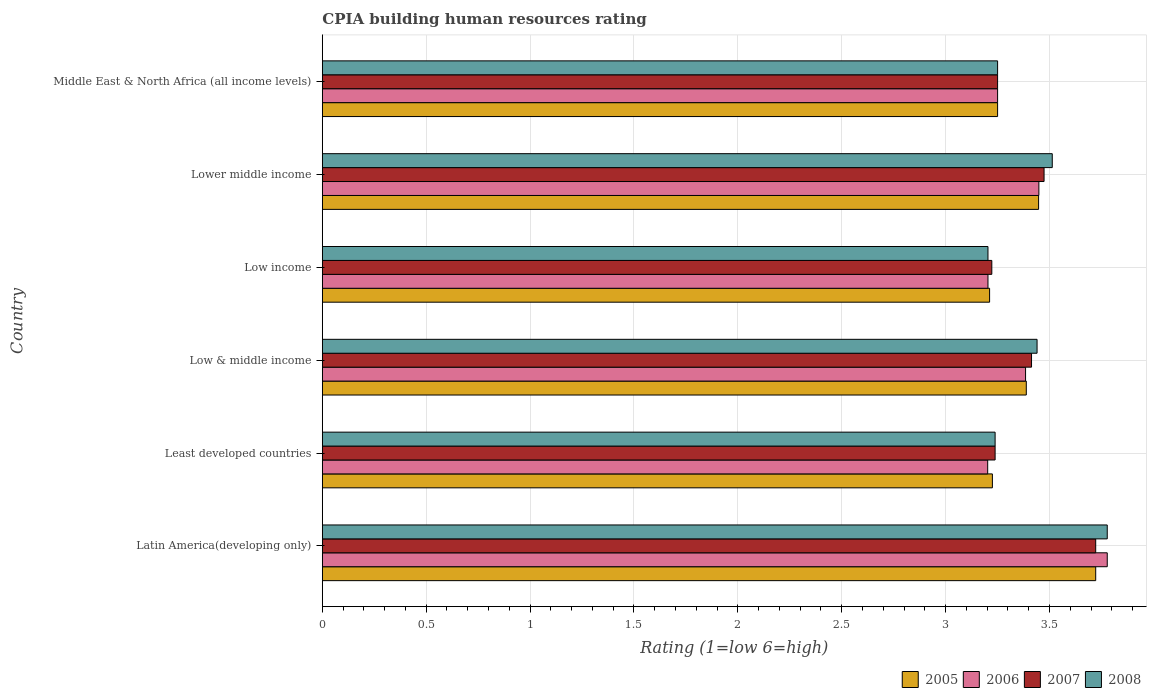How many groups of bars are there?
Keep it short and to the point. 6. Are the number of bars per tick equal to the number of legend labels?
Your answer should be very brief. Yes. How many bars are there on the 3rd tick from the top?
Give a very brief answer. 4. What is the label of the 1st group of bars from the top?
Keep it short and to the point. Middle East & North Africa (all income levels). Across all countries, what is the maximum CPIA rating in 2006?
Provide a succinct answer. 3.78. Across all countries, what is the minimum CPIA rating in 2006?
Offer a very short reply. 3.2. In which country was the CPIA rating in 2005 maximum?
Your answer should be compact. Latin America(developing only). What is the total CPIA rating in 2005 in the graph?
Offer a terse response. 20.24. What is the difference between the CPIA rating in 2006 in Latin America(developing only) and that in Low income?
Offer a very short reply. 0.57. What is the difference between the CPIA rating in 2008 in Lower middle income and the CPIA rating in 2005 in Least developed countries?
Provide a short and direct response. 0.29. What is the average CPIA rating in 2008 per country?
Offer a very short reply. 3.4. What is the difference between the CPIA rating in 2005 and CPIA rating in 2006 in Low income?
Offer a very short reply. 0.01. In how many countries, is the CPIA rating in 2008 greater than 0.1 ?
Offer a terse response. 6. What is the ratio of the CPIA rating in 2008 in Low & middle income to that in Middle East & North Africa (all income levels)?
Your answer should be compact. 1.06. What is the difference between the highest and the second highest CPIA rating in 2007?
Offer a very short reply. 0.25. What is the difference between the highest and the lowest CPIA rating in 2006?
Make the answer very short. 0.58. Is it the case that in every country, the sum of the CPIA rating in 2008 and CPIA rating in 2006 is greater than the sum of CPIA rating in 2005 and CPIA rating in 2007?
Provide a short and direct response. No. What does the 1st bar from the bottom in Lower middle income represents?
Offer a very short reply. 2005. How many bars are there?
Make the answer very short. 24. How many countries are there in the graph?
Your answer should be very brief. 6. What is the difference between two consecutive major ticks on the X-axis?
Ensure brevity in your answer.  0.5. Does the graph contain any zero values?
Offer a terse response. No. Where does the legend appear in the graph?
Make the answer very short. Bottom right. How are the legend labels stacked?
Your answer should be compact. Horizontal. What is the title of the graph?
Make the answer very short. CPIA building human resources rating. What is the Rating (1=low 6=high) of 2005 in Latin America(developing only)?
Keep it short and to the point. 3.72. What is the Rating (1=low 6=high) in 2006 in Latin America(developing only)?
Provide a succinct answer. 3.78. What is the Rating (1=low 6=high) of 2007 in Latin America(developing only)?
Give a very brief answer. 3.72. What is the Rating (1=low 6=high) of 2008 in Latin America(developing only)?
Keep it short and to the point. 3.78. What is the Rating (1=low 6=high) of 2005 in Least developed countries?
Ensure brevity in your answer.  3.23. What is the Rating (1=low 6=high) in 2006 in Least developed countries?
Keep it short and to the point. 3.2. What is the Rating (1=low 6=high) in 2007 in Least developed countries?
Make the answer very short. 3.24. What is the Rating (1=low 6=high) of 2008 in Least developed countries?
Offer a terse response. 3.24. What is the Rating (1=low 6=high) in 2005 in Low & middle income?
Ensure brevity in your answer.  3.39. What is the Rating (1=low 6=high) in 2006 in Low & middle income?
Your response must be concise. 3.38. What is the Rating (1=low 6=high) in 2007 in Low & middle income?
Provide a short and direct response. 3.41. What is the Rating (1=low 6=high) in 2008 in Low & middle income?
Offer a very short reply. 3.44. What is the Rating (1=low 6=high) in 2005 in Low income?
Your response must be concise. 3.21. What is the Rating (1=low 6=high) of 2006 in Low income?
Keep it short and to the point. 3.2. What is the Rating (1=low 6=high) in 2007 in Low income?
Keep it short and to the point. 3.22. What is the Rating (1=low 6=high) of 2008 in Low income?
Offer a very short reply. 3.2. What is the Rating (1=low 6=high) in 2005 in Lower middle income?
Make the answer very short. 3.45. What is the Rating (1=low 6=high) in 2006 in Lower middle income?
Offer a very short reply. 3.45. What is the Rating (1=low 6=high) in 2007 in Lower middle income?
Ensure brevity in your answer.  3.47. What is the Rating (1=low 6=high) in 2008 in Lower middle income?
Provide a short and direct response. 3.51. What is the Rating (1=low 6=high) of 2006 in Middle East & North Africa (all income levels)?
Give a very brief answer. 3.25. Across all countries, what is the maximum Rating (1=low 6=high) of 2005?
Your response must be concise. 3.72. Across all countries, what is the maximum Rating (1=low 6=high) of 2006?
Provide a succinct answer. 3.78. Across all countries, what is the maximum Rating (1=low 6=high) of 2007?
Offer a terse response. 3.72. Across all countries, what is the maximum Rating (1=low 6=high) of 2008?
Make the answer very short. 3.78. Across all countries, what is the minimum Rating (1=low 6=high) in 2005?
Give a very brief answer. 3.21. Across all countries, what is the minimum Rating (1=low 6=high) of 2006?
Your answer should be very brief. 3.2. Across all countries, what is the minimum Rating (1=low 6=high) of 2007?
Offer a terse response. 3.22. Across all countries, what is the minimum Rating (1=low 6=high) of 2008?
Make the answer very short. 3.2. What is the total Rating (1=low 6=high) of 2005 in the graph?
Keep it short and to the point. 20.24. What is the total Rating (1=low 6=high) in 2006 in the graph?
Provide a short and direct response. 20.27. What is the total Rating (1=low 6=high) of 2007 in the graph?
Offer a very short reply. 20.32. What is the total Rating (1=low 6=high) in 2008 in the graph?
Offer a very short reply. 20.42. What is the difference between the Rating (1=low 6=high) of 2005 in Latin America(developing only) and that in Least developed countries?
Your answer should be compact. 0.5. What is the difference between the Rating (1=low 6=high) in 2006 in Latin America(developing only) and that in Least developed countries?
Make the answer very short. 0.58. What is the difference between the Rating (1=low 6=high) of 2007 in Latin America(developing only) and that in Least developed countries?
Provide a succinct answer. 0.48. What is the difference between the Rating (1=low 6=high) in 2008 in Latin America(developing only) and that in Least developed countries?
Keep it short and to the point. 0.54. What is the difference between the Rating (1=low 6=high) of 2005 in Latin America(developing only) and that in Low & middle income?
Your answer should be very brief. 0.33. What is the difference between the Rating (1=low 6=high) in 2006 in Latin America(developing only) and that in Low & middle income?
Your answer should be very brief. 0.39. What is the difference between the Rating (1=low 6=high) in 2007 in Latin America(developing only) and that in Low & middle income?
Your answer should be compact. 0.31. What is the difference between the Rating (1=low 6=high) of 2008 in Latin America(developing only) and that in Low & middle income?
Offer a terse response. 0.34. What is the difference between the Rating (1=low 6=high) in 2005 in Latin America(developing only) and that in Low income?
Keep it short and to the point. 0.51. What is the difference between the Rating (1=low 6=high) in 2006 in Latin America(developing only) and that in Low income?
Provide a succinct answer. 0.57. What is the difference between the Rating (1=low 6=high) in 2007 in Latin America(developing only) and that in Low income?
Offer a very short reply. 0.5. What is the difference between the Rating (1=low 6=high) in 2008 in Latin America(developing only) and that in Low income?
Offer a terse response. 0.57. What is the difference between the Rating (1=low 6=high) in 2005 in Latin America(developing only) and that in Lower middle income?
Your answer should be very brief. 0.27. What is the difference between the Rating (1=low 6=high) of 2006 in Latin America(developing only) and that in Lower middle income?
Offer a very short reply. 0.33. What is the difference between the Rating (1=low 6=high) in 2007 in Latin America(developing only) and that in Lower middle income?
Make the answer very short. 0.25. What is the difference between the Rating (1=low 6=high) in 2008 in Latin America(developing only) and that in Lower middle income?
Provide a succinct answer. 0.26. What is the difference between the Rating (1=low 6=high) of 2005 in Latin America(developing only) and that in Middle East & North Africa (all income levels)?
Ensure brevity in your answer.  0.47. What is the difference between the Rating (1=low 6=high) in 2006 in Latin America(developing only) and that in Middle East & North Africa (all income levels)?
Give a very brief answer. 0.53. What is the difference between the Rating (1=low 6=high) in 2007 in Latin America(developing only) and that in Middle East & North Africa (all income levels)?
Ensure brevity in your answer.  0.47. What is the difference between the Rating (1=low 6=high) in 2008 in Latin America(developing only) and that in Middle East & North Africa (all income levels)?
Provide a succinct answer. 0.53. What is the difference between the Rating (1=low 6=high) in 2005 in Least developed countries and that in Low & middle income?
Offer a very short reply. -0.16. What is the difference between the Rating (1=low 6=high) in 2006 in Least developed countries and that in Low & middle income?
Provide a succinct answer. -0.18. What is the difference between the Rating (1=low 6=high) in 2007 in Least developed countries and that in Low & middle income?
Your answer should be compact. -0.18. What is the difference between the Rating (1=low 6=high) of 2008 in Least developed countries and that in Low & middle income?
Ensure brevity in your answer.  -0.2. What is the difference between the Rating (1=low 6=high) in 2005 in Least developed countries and that in Low income?
Your answer should be compact. 0.01. What is the difference between the Rating (1=low 6=high) of 2006 in Least developed countries and that in Low income?
Provide a short and direct response. -0. What is the difference between the Rating (1=low 6=high) in 2007 in Least developed countries and that in Low income?
Offer a very short reply. 0.02. What is the difference between the Rating (1=low 6=high) of 2008 in Least developed countries and that in Low income?
Make the answer very short. 0.03. What is the difference between the Rating (1=low 6=high) of 2005 in Least developed countries and that in Lower middle income?
Your response must be concise. -0.22. What is the difference between the Rating (1=low 6=high) of 2006 in Least developed countries and that in Lower middle income?
Provide a succinct answer. -0.25. What is the difference between the Rating (1=low 6=high) in 2007 in Least developed countries and that in Lower middle income?
Your response must be concise. -0.24. What is the difference between the Rating (1=low 6=high) in 2008 in Least developed countries and that in Lower middle income?
Your response must be concise. -0.28. What is the difference between the Rating (1=low 6=high) in 2005 in Least developed countries and that in Middle East & North Africa (all income levels)?
Give a very brief answer. -0.03. What is the difference between the Rating (1=low 6=high) in 2006 in Least developed countries and that in Middle East & North Africa (all income levels)?
Your response must be concise. -0.05. What is the difference between the Rating (1=low 6=high) of 2007 in Least developed countries and that in Middle East & North Africa (all income levels)?
Make the answer very short. -0.01. What is the difference between the Rating (1=low 6=high) in 2008 in Least developed countries and that in Middle East & North Africa (all income levels)?
Offer a terse response. -0.01. What is the difference between the Rating (1=low 6=high) of 2005 in Low & middle income and that in Low income?
Offer a terse response. 0.18. What is the difference between the Rating (1=low 6=high) in 2006 in Low & middle income and that in Low income?
Your answer should be compact. 0.18. What is the difference between the Rating (1=low 6=high) of 2007 in Low & middle income and that in Low income?
Give a very brief answer. 0.19. What is the difference between the Rating (1=low 6=high) in 2008 in Low & middle income and that in Low income?
Your response must be concise. 0.24. What is the difference between the Rating (1=low 6=high) of 2005 in Low & middle income and that in Lower middle income?
Keep it short and to the point. -0.06. What is the difference between the Rating (1=low 6=high) of 2006 in Low & middle income and that in Lower middle income?
Offer a terse response. -0.06. What is the difference between the Rating (1=low 6=high) in 2007 in Low & middle income and that in Lower middle income?
Your answer should be compact. -0.06. What is the difference between the Rating (1=low 6=high) in 2008 in Low & middle income and that in Lower middle income?
Keep it short and to the point. -0.07. What is the difference between the Rating (1=low 6=high) of 2005 in Low & middle income and that in Middle East & North Africa (all income levels)?
Your answer should be very brief. 0.14. What is the difference between the Rating (1=low 6=high) of 2006 in Low & middle income and that in Middle East & North Africa (all income levels)?
Your answer should be very brief. 0.13. What is the difference between the Rating (1=low 6=high) in 2007 in Low & middle income and that in Middle East & North Africa (all income levels)?
Ensure brevity in your answer.  0.16. What is the difference between the Rating (1=low 6=high) of 2008 in Low & middle income and that in Middle East & North Africa (all income levels)?
Your answer should be very brief. 0.19. What is the difference between the Rating (1=low 6=high) in 2005 in Low income and that in Lower middle income?
Provide a succinct answer. -0.24. What is the difference between the Rating (1=low 6=high) of 2006 in Low income and that in Lower middle income?
Provide a short and direct response. -0.24. What is the difference between the Rating (1=low 6=high) of 2007 in Low income and that in Lower middle income?
Make the answer very short. -0.25. What is the difference between the Rating (1=low 6=high) in 2008 in Low income and that in Lower middle income?
Your answer should be very brief. -0.31. What is the difference between the Rating (1=low 6=high) of 2005 in Low income and that in Middle East & North Africa (all income levels)?
Your answer should be very brief. -0.04. What is the difference between the Rating (1=low 6=high) of 2006 in Low income and that in Middle East & North Africa (all income levels)?
Offer a very short reply. -0.05. What is the difference between the Rating (1=low 6=high) of 2007 in Low income and that in Middle East & North Africa (all income levels)?
Offer a very short reply. -0.03. What is the difference between the Rating (1=low 6=high) in 2008 in Low income and that in Middle East & North Africa (all income levels)?
Provide a short and direct response. -0.05. What is the difference between the Rating (1=low 6=high) of 2005 in Lower middle income and that in Middle East & North Africa (all income levels)?
Ensure brevity in your answer.  0.2. What is the difference between the Rating (1=low 6=high) in 2006 in Lower middle income and that in Middle East & North Africa (all income levels)?
Keep it short and to the point. 0.2. What is the difference between the Rating (1=low 6=high) of 2007 in Lower middle income and that in Middle East & North Africa (all income levels)?
Provide a short and direct response. 0.22. What is the difference between the Rating (1=low 6=high) of 2008 in Lower middle income and that in Middle East & North Africa (all income levels)?
Your answer should be compact. 0.26. What is the difference between the Rating (1=low 6=high) of 2005 in Latin America(developing only) and the Rating (1=low 6=high) of 2006 in Least developed countries?
Ensure brevity in your answer.  0.52. What is the difference between the Rating (1=low 6=high) in 2005 in Latin America(developing only) and the Rating (1=low 6=high) in 2007 in Least developed countries?
Offer a very short reply. 0.48. What is the difference between the Rating (1=low 6=high) of 2005 in Latin America(developing only) and the Rating (1=low 6=high) of 2008 in Least developed countries?
Offer a terse response. 0.48. What is the difference between the Rating (1=low 6=high) of 2006 in Latin America(developing only) and the Rating (1=low 6=high) of 2007 in Least developed countries?
Make the answer very short. 0.54. What is the difference between the Rating (1=low 6=high) of 2006 in Latin America(developing only) and the Rating (1=low 6=high) of 2008 in Least developed countries?
Provide a succinct answer. 0.54. What is the difference between the Rating (1=low 6=high) of 2007 in Latin America(developing only) and the Rating (1=low 6=high) of 2008 in Least developed countries?
Make the answer very short. 0.48. What is the difference between the Rating (1=low 6=high) of 2005 in Latin America(developing only) and the Rating (1=low 6=high) of 2006 in Low & middle income?
Make the answer very short. 0.34. What is the difference between the Rating (1=low 6=high) of 2005 in Latin America(developing only) and the Rating (1=low 6=high) of 2007 in Low & middle income?
Provide a succinct answer. 0.31. What is the difference between the Rating (1=low 6=high) of 2005 in Latin America(developing only) and the Rating (1=low 6=high) of 2008 in Low & middle income?
Provide a short and direct response. 0.28. What is the difference between the Rating (1=low 6=high) of 2006 in Latin America(developing only) and the Rating (1=low 6=high) of 2007 in Low & middle income?
Provide a succinct answer. 0.36. What is the difference between the Rating (1=low 6=high) of 2006 in Latin America(developing only) and the Rating (1=low 6=high) of 2008 in Low & middle income?
Ensure brevity in your answer.  0.34. What is the difference between the Rating (1=low 6=high) of 2007 in Latin America(developing only) and the Rating (1=low 6=high) of 2008 in Low & middle income?
Your response must be concise. 0.28. What is the difference between the Rating (1=low 6=high) of 2005 in Latin America(developing only) and the Rating (1=low 6=high) of 2006 in Low income?
Your response must be concise. 0.52. What is the difference between the Rating (1=low 6=high) in 2005 in Latin America(developing only) and the Rating (1=low 6=high) in 2008 in Low income?
Provide a short and direct response. 0.52. What is the difference between the Rating (1=low 6=high) of 2006 in Latin America(developing only) and the Rating (1=low 6=high) of 2007 in Low income?
Offer a terse response. 0.56. What is the difference between the Rating (1=low 6=high) of 2006 in Latin America(developing only) and the Rating (1=low 6=high) of 2008 in Low income?
Your answer should be compact. 0.57. What is the difference between the Rating (1=low 6=high) of 2007 in Latin America(developing only) and the Rating (1=low 6=high) of 2008 in Low income?
Give a very brief answer. 0.52. What is the difference between the Rating (1=low 6=high) of 2005 in Latin America(developing only) and the Rating (1=low 6=high) of 2006 in Lower middle income?
Offer a terse response. 0.27. What is the difference between the Rating (1=low 6=high) in 2005 in Latin America(developing only) and the Rating (1=low 6=high) in 2007 in Lower middle income?
Ensure brevity in your answer.  0.25. What is the difference between the Rating (1=low 6=high) of 2005 in Latin America(developing only) and the Rating (1=low 6=high) of 2008 in Lower middle income?
Your response must be concise. 0.21. What is the difference between the Rating (1=low 6=high) of 2006 in Latin America(developing only) and the Rating (1=low 6=high) of 2007 in Lower middle income?
Give a very brief answer. 0.3. What is the difference between the Rating (1=low 6=high) of 2006 in Latin America(developing only) and the Rating (1=low 6=high) of 2008 in Lower middle income?
Ensure brevity in your answer.  0.26. What is the difference between the Rating (1=low 6=high) of 2007 in Latin America(developing only) and the Rating (1=low 6=high) of 2008 in Lower middle income?
Ensure brevity in your answer.  0.21. What is the difference between the Rating (1=low 6=high) of 2005 in Latin America(developing only) and the Rating (1=low 6=high) of 2006 in Middle East & North Africa (all income levels)?
Provide a short and direct response. 0.47. What is the difference between the Rating (1=low 6=high) of 2005 in Latin America(developing only) and the Rating (1=low 6=high) of 2007 in Middle East & North Africa (all income levels)?
Your response must be concise. 0.47. What is the difference between the Rating (1=low 6=high) in 2005 in Latin America(developing only) and the Rating (1=low 6=high) in 2008 in Middle East & North Africa (all income levels)?
Offer a terse response. 0.47. What is the difference between the Rating (1=low 6=high) in 2006 in Latin America(developing only) and the Rating (1=low 6=high) in 2007 in Middle East & North Africa (all income levels)?
Your response must be concise. 0.53. What is the difference between the Rating (1=low 6=high) in 2006 in Latin America(developing only) and the Rating (1=low 6=high) in 2008 in Middle East & North Africa (all income levels)?
Give a very brief answer. 0.53. What is the difference between the Rating (1=low 6=high) in 2007 in Latin America(developing only) and the Rating (1=low 6=high) in 2008 in Middle East & North Africa (all income levels)?
Your response must be concise. 0.47. What is the difference between the Rating (1=low 6=high) of 2005 in Least developed countries and the Rating (1=low 6=high) of 2006 in Low & middle income?
Provide a short and direct response. -0.16. What is the difference between the Rating (1=low 6=high) of 2005 in Least developed countries and the Rating (1=low 6=high) of 2007 in Low & middle income?
Your response must be concise. -0.19. What is the difference between the Rating (1=low 6=high) of 2005 in Least developed countries and the Rating (1=low 6=high) of 2008 in Low & middle income?
Your response must be concise. -0.21. What is the difference between the Rating (1=low 6=high) of 2006 in Least developed countries and the Rating (1=low 6=high) of 2007 in Low & middle income?
Your answer should be very brief. -0.21. What is the difference between the Rating (1=low 6=high) of 2006 in Least developed countries and the Rating (1=low 6=high) of 2008 in Low & middle income?
Your answer should be very brief. -0.24. What is the difference between the Rating (1=low 6=high) of 2007 in Least developed countries and the Rating (1=low 6=high) of 2008 in Low & middle income?
Your answer should be very brief. -0.2. What is the difference between the Rating (1=low 6=high) in 2005 in Least developed countries and the Rating (1=low 6=high) in 2006 in Low income?
Provide a succinct answer. 0.02. What is the difference between the Rating (1=low 6=high) in 2005 in Least developed countries and the Rating (1=low 6=high) in 2007 in Low income?
Give a very brief answer. 0. What is the difference between the Rating (1=low 6=high) in 2005 in Least developed countries and the Rating (1=low 6=high) in 2008 in Low income?
Provide a succinct answer. 0.02. What is the difference between the Rating (1=low 6=high) of 2006 in Least developed countries and the Rating (1=low 6=high) of 2007 in Low income?
Make the answer very short. -0.02. What is the difference between the Rating (1=low 6=high) in 2006 in Least developed countries and the Rating (1=low 6=high) in 2008 in Low income?
Provide a short and direct response. -0. What is the difference between the Rating (1=low 6=high) of 2007 in Least developed countries and the Rating (1=low 6=high) of 2008 in Low income?
Your response must be concise. 0.03. What is the difference between the Rating (1=low 6=high) of 2005 in Least developed countries and the Rating (1=low 6=high) of 2006 in Lower middle income?
Your answer should be very brief. -0.22. What is the difference between the Rating (1=low 6=high) of 2005 in Least developed countries and the Rating (1=low 6=high) of 2007 in Lower middle income?
Ensure brevity in your answer.  -0.25. What is the difference between the Rating (1=low 6=high) in 2005 in Least developed countries and the Rating (1=low 6=high) in 2008 in Lower middle income?
Offer a very short reply. -0.29. What is the difference between the Rating (1=low 6=high) in 2006 in Least developed countries and the Rating (1=low 6=high) in 2007 in Lower middle income?
Provide a short and direct response. -0.27. What is the difference between the Rating (1=low 6=high) of 2006 in Least developed countries and the Rating (1=low 6=high) of 2008 in Lower middle income?
Your answer should be very brief. -0.31. What is the difference between the Rating (1=low 6=high) of 2007 in Least developed countries and the Rating (1=low 6=high) of 2008 in Lower middle income?
Make the answer very short. -0.28. What is the difference between the Rating (1=low 6=high) of 2005 in Least developed countries and the Rating (1=low 6=high) of 2006 in Middle East & North Africa (all income levels)?
Provide a succinct answer. -0.03. What is the difference between the Rating (1=low 6=high) in 2005 in Least developed countries and the Rating (1=low 6=high) in 2007 in Middle East & North Africa (all income levels)?
Your answer should be compact. -0.03. What is the difference between the Rating (1=low 6=high) of 2005 in Least developed countries and the Rating (1=low 6=high) of 2008 in Middle East & North Africa (all income levels)?
Give a very brief answer. -0.03. What is the difference between the Rating (1=low 6=high) in 2006 in Least developed countries and the Rating (1=low 6=high) in 2007 in Middle East & North Africa (all income levels)?
Your answer should be compact. -0.05. What is the difference between the Rating (1=low 6=high) of 2006 in Least developed countries and the Rating (1=low 6=high) of 2008 in Middle East & North Africa (all income levels)?
Your answer should be very brief. -0.05. What is the difference between the Rating (1=low 6=high) in 2007 in Least developed countries and the Rating (1=low 6=high) in 2008 in Middle East & North Africa (all income levels)?
Offer a very short reply. -0.01. What is the difference between the Rating (1=low 6=high) of 2005 in Low & middle income and the Rating (1=low 6=high) of 2006 in Low income?
Make the answer very short. 0.18. What is the difference between the Rating (1=low 6=high) in 2005 in Low & middle income and the Rating (1=low 6=high) in 2007 in Low income?
Keep it short and to the point. 0.17. What is the difference between the Rating (1=low 6=high) of 2005 in Low & middle income and the Rating (1=low 6=high) of 2008 in Low income?
Provide a short and direct response. 0.18. What is the difference between the Rating (1=low 6=high) of 2006 in Low & middle income and the Rating (1=low 6=high) of 2007 in Low income?
Offer a terse response. 0.16. What is the difference between the Rating (1=low 6=high) of 2006 in Low & middle income and the Rating (1=low 6=high) of 2008 in Low income?
Offer a terse response. 0.18. What is the difference between the Rating (1=low 6=high) of 2007 in Low & middle income and the Rating (1=low 6=high) of 2008 in Low income?
Keep it short and to the point. 0.21. What is the difference between the Rating (1=low 6=high) in 2005 in Low & middle income and the Rating (1=low 6=high) in 2006 in Lower middle income?
Give a very brief answer. -0.06. What is the difference between the Rating (1=low 6=high) of 2005 in Low & middle income and the Rating (1=low 6=high) of 2007 in Lower middle income?
Give a very brief answer. -0.09. What is the difference between the Rating (1=low 6=high) in 2005 in Low & middle income and the Rating (1=low 6=high) in 2008 in Lower middle income?
Offer a terse response. -0.12. What is the difference between the Rating (1=low 6=high) of 2006 in Low & middle income and the Rating (1=low 6=high) of 2007 in Lower middle income?
Offer a terse response. -0.09. What is the difference between the Rating (1=low 6=high) in 2006 in Low & middle income and the Rating (1=low 6=high) in 2008 in Lower middle income?
Your response must be concise. -0.13. What is the difference between the Rating (1=low 6=high) of 2007 in Low & middle income and the Rating (1=low 6=high) of 2008 in Lower middle income?
Offer a terse response. -0.1. What is the difference between the Rating (1=low 6=high) in 2005 in Low & middle income and the Rating (1=low 6=high) in 2006 in Middle East & North Africa (all income levels)?
Offer a terse response. 0.14. What is the difference between the Rating (1=low 6=high) in 2005 in Low & middle income and the Rating (1=low 6=high) in 2007 in Middle East & North Africa (all income levels)?
Ensure brevity in your answer.  0.14. What is the difference between the Rating (1=low 6=high) in 2005 in Low & middle income and the Rating (1=low 6=high) in 2008 in Middle East & North Africa (all income levels)?
Provide a short and direct response. 0.14. What is the difference between the Rating (1=low 6=high) of 2006 in Low & middle income and the Rating (1=low 6=high) of 2007 in Middle East & North Africa (all income levels)?
Your response must be concise. 0.13. What is the difference between the Rating (1=low 6=high) of 2006 in Low & middle income and the Rating (1=low 6=high) of 2008 in Middle East & North Africa (all income levels)?
Your response must be concise. 0.13. What is the difference between the Rating (1=low 6=high) of 2007 in Low & middle income and the Rating (1=low 6=high) of 2008 in Middle East & North Africa (all income levels)?
Offer a terse response. 0.16. What is the difference between the Rating (1=low 6=high) of 2005 in Low income and the Rating (1=low 6=high) of 2006 in Lower middle income?
Give a very brief answer. -0.24. What is the difference between the Rating (1=low 6=high) in 2005 in Low income and the Rating (1=low 6=high) in 2007 in Lower middle income?
Your answer should be very brief. -0.26. What is the difference between the Rating (1=low 6=high) of 2005 in Low income and the Rating (1=low 6=high) of 2008 in Lower middle income?
Ensure brevity in your answer.  -0.3. What is the difference between the Rating (1=low 6=high) in 2006 in Low income and the Rating (1=low 6=high) in 2007 in Lower middle income?
Your answer should be compact. -0.27. What is the difference between the Rating (1=low 6=high) in 2006 in Low income and the Rating (1=low 6=high) in 2008 in Lower middle income?
Provide a succinct answer. -0.31. What is the difference between the Rating (1=low 6=high) of 2007 in Low income and the Rating (1=low 6=high) of 2008 in Lower middle income?
Keep it short and to the point. -0.29. What is the difference between the Rating (1=low 6=high) in 2005 in Low income and the Rating (1=low 6=high) in 2006 in Middle East & North Africa (all income levels)?
Provide a short and direct response. -0.04. What is the difference between the Rating (1=low 6=high) of 2005 in Low income and the Rating (1=low 6=high) of 2007 in Middle East & North Africa (all income levels)?
Ensure brevity in your answer.  -0.04. What is the difference between the Rating (1=low 6=high) in 2005 in Low income and the Rating (1=low 6=high) in 2008 in Middle East & North Africa (all income levels)?
Your response must be concise. -0.04. What is the difference between the Rating (1=low 6=high) of 2006 in Low income and the Rating (1=low 6=high) of 2007 in Middle East & North Africa (all income levels)?
Offer a very short reply. -0.05. What is the difference between the Rating (1=low 6=high) of 2006 in Low income and the Rating (1=low 6=high) of 2008 in Middle East & North Africa (all income levels)?
Your response must be concise. -0.05. What is the difference between the Rating (1=low 6=high) in 2007 in Low income and the Rating (1=low 6=high) in 2008 in Middle East & North Africa (all income levels)?
Make the answer very short. -0.03. What is the difference between the Rating (1=low 6=high) of 2005 in Lower middle income and the Rating (1=low 6=high) of 2006 in Middle East & North Africa (all income levels)?
Give a very brief answer. 0.2. What is the difference between the Rating (1=low 6=high) of 2005 in Lower middle income and the Rating (1=low 6=high) of 2007 in Middle East & North Africa (all income levels)?
Offer a terse response. 0.2. What is the difference between the Rating (1=low 6=high) in 2005 in Lower middle income and the Rating (1=low 6=high) in 2008 in Middle East & North Africa (all income levels)?
Offer a terse response. 0.2. What is the difference between the Rating (1=low 6=high) in 2006 in Lower middle income and the Rating (1=low 6=high) in 2007 in Middle East & North Africa (all income levels)?
Offer a terse response. 0.2. What is the difference between the Rating (1=low 6=high) in 2006 in Lower middle income and the Rating (1=low 6=high) in 2008 in Middle East & North Africa (all income levels)?
Your answer should be very brief. 0.2. What is the difference between the Rating (1=low 6=high) in 2007 in Lower middle income and the Rating (1=low 6=high) in 2008 in Middle East & North Africa (all income levels)?
Provide a succinct answer. 0.22. What is the average Rating (1=low 6=high) of 2005 per country?
Offer a terse response. 3.37. What is the average Rating (1=low 6=high) in 2006 per country?
Your answer should be compact. 3.38. What is the average Rating (1=low 6=high) of 2007 per country?
Give a very brief answer. 3.39. What is the average Rating (1=low 6=high) of 2008 per country?
Give a very brief answer. 3.4. What is the difference between the Rating (1=low 6=high) of 2005 and Rating (1=low 6=high) of 2006 in Latin America(developing only)?
Your answer should be very brief. -0.06. What is the difference between the Rating (1=low 6=high) of 2005 and Rating (1=low 6=high) of 2008 in Latin America(developing only)?
Provide a short and direct response. -0.06. What is the difference between the Rating (1=low 6=high) in 2006 and Rating (1=low 6=high) in 2007 in Latin America(developing only)?
Provide a succinct answer. 0.06. What is the difference between the Rating (1=low 6=high) in 2007 and Rating (1=low 6=high) in 2008 in Latin America(developing only)?
Your response must be concise. -0.06. What is the difference between the Rating (1=low 6=high) of 2005 and Rating (1=low 6=high) of 2006 in Least developed countries?
Make the answer very short. 0.02. What is the difference between the Rating (1=low 6=high) in 2005 and Rating (1=low 6=high) in 2007 in Least developed countries?
Offer a terse response. -0.01. What is the difference between the Rating (1=low 6=high) of 2005 and Rating (1=low 6=high) of 2008 in Least developed countries?
Ensure brevity in your answer.  -0.01. What is the difference between the Rating (1=low 6=high) of 2006 and Rating (1=low 6=high) of 2007 in Least developed countries?
Give a very brief answer. -0.04. What is the difference between the Rating (1=low 6=high) of 2006 and Rating (1=low 6=high) of 2008 in Least developed countries?
Keep it short and to the point. -0.04. What is the difference between the Rating (1=low 6=high) in 2005 and Rating (1=low 6=high) in 2006 in Low & middle income?
Your response must be concise. 0. What is the difference between the Rating (1=low 6=high) of 2005 and Rating (1=low 6=high) of 2007 in Low & middle income?
Keep it short and to the point. -0.03. What is the difference between the Rating (1=low 6=high) in 2005 and Rating (1=low 6=high) in 2008 in Low & middle income?
Offer a very short reply. -0.05. What is the difference between the Rating (1=low 6=high) of 2006 and Rating (1=low 6=high) of 2007 in Low & middle income?
Your answer should be very brief. -0.03. What is the difference between the Rating (1=low 6=high) in 2006 and Rating (1=low 6=high) in 2008 in Low & middle income?
Your answer should be very brief. -0.06. What is the difference between the Rating (1=low 6=high) of 2007 and Rating (1=low 6=high) of 2008 in Low & middle income?
Provide a short and direct response. -0.03. What is the difference between the Rating (1=low 6=high) of 2005 and Rating (1=low 6=high) of 2006 in Low income?
Provide a succinct answer. 0.01. What is the difference between the Rating (1=low 6=high) of 2005 and Rating (1=low 6=high) of 2007 in Low income?
Make the answer very short. -0.01. What is the difference between the Rating (1=low 6=high) in 2005 and Rating (1=low 6=high) in 2008 in Low income?
Offer a terse response. 0.01. What is the difference between the Rating (1=low 6=high) in 2006 and Rating (1=low 6=high) in 2007 in Low income?
Your response must be concise. -0.02. What is the difference between the Rating (1=low 6=high) of 2006 and Rating (1=low 6=high) of 2008 in Low income?
Provide a short and direct response. 0. What is the difference between the Rating (1=low 6=high) in 2007 and Rating (1=low 6=high) in 2008 in Low income?
Your response must be concise. 0.02. What is the difference between the Rating (1=low 6=high) of 2005 and Rating (1=low 6=high) of 2006 in Lower middle income?
Your answer should be compact. -0. What is the difference between the Rating (1=low 6=high) in 2005 and Rating (1=low 6=high) in 2007 in Lower middle income?
Offer a very short reply. -0.03. What is the difference between the Rating (1=low 6=high) in 2005 and Rating (1=low 6=high) in 2008 in Lower middle income?
Make the answer very short. -0.07. What is the difference between the Rating (1=low 6=high) of 2006 and Rating (1=low 6=high) of 2007 in Lower middle income?
Offer a terse response. -0.03. What is the difference between the Rating (1=low 6=high) in 2006 and Rating (1=low 6=high) in 2008 in Lower middle income?
Make the answer very short. -0.06. What is the difference between the Rating (1=low 6=high) of 2007 and Rating (1=low 6=high) of 2008 in Lower middle income?
Your answer should be compact. -0.04. What is the difference between the Rating (1=low 6=high) of 2007 and Rating (1=low 6=high) of 2008 in Middle East & North Africa (all income levels)?
Make the answer very short. 0. What is the ratio of the Rating (1=low 6=high) in 2005 in Latin America(developing only) to that in Least developed countries?
Your answer should be compact. 1.15. What is the ratio of the Rating (1=low 6=high) in 2006 in Latin America(developing only) to that in Least developed countries?
Your answer should be compact. 1.18. What is the ratio of the Rating (1=low 6=high) in 2007 in Latin America(developing only) to that in Least developed countries?
Your response must be concise. 1.15. What is the ratio of the Rating (1=low 6=high) of 2008 in Latin America(developing only) to that in Least developed countries?
Offer a very short reply. 1.17. What is the ratio of the Rating (1=low 6=high) in 2005 in Latin America(developing only) to that in Low & middle income?
Ensure brevity in your answer.  1.1. What is the ratio of the Rating (1=low 6=high) of 2006 in Latin America(developing only) to that in Low & middle income?
Ensure brevity in your answer.  1.12. What is the ratio of the Rating (1=low 6=high) in 2007 in Latin America(developing only) to that in Low & middle income?
Give a very brief answer. 1.09. What is the ratio of the Rating (1=low 6=high) in 2008 in Latin America(developing only) to that in Low & middle income?
Give a very brief answer. 1.1. What is the ratio of the Rating (1=low 6=high) of 2005 in Latin America(developing only) to that in Low income?
Keep it short and to the point. 1.16. What is the ratio of the Rating (1=low 6=high) in 2006 in Latin America(developing only) to that in Low income?
Provide a short and direct response. 1.18. What is the ratio of the Rating (1=low 6=high) of 2007 in Latin America(developing only) to that in Low income?
Ensure brevity in your answer.  1.16. What is the ratio of the Rating (1=low 6=high) of 2008 in Latin America(developing only) to that in Low income?
Provide a succinct answer. 1.18. What is the ratio of the Rating (1=low 6=high) of 2005 in Latin America(developing only) to that in Lower middle income?
Your response must be concise. 1.08. What is the ratio of the Rating (1=low 6=high) of 2006 in Latin America(developing only) to that in Lower middle income?
Your answer should be compact. 1.1. What is the ratio of the Rating (1=low 6=high) in 2007 in Latin America(developing only) to that in Lower middle income?
Ensure brevity in your answer.  1.07. What is the ratio of the Rating (1=low 6=high) of 2008 in Latin America(developing only) to that in Lower middle income?
Your answer should be very brief. 1.08. What is the ratio of the Rating (1=low 6=high) of 2005 in Latin America(developing only) to that in Middle East & North Africa (all income levels)?
Offer a terse response. 1.15. What is the ratio of the Rating (1=low 6=high) in 2006 in Latin America(developing only) to that in Middle East & North Africa (all income levels)?
Keep it short and to the point. 1.16. What is the ratio of the Rating (1=low 6=high) in 2007 in Latin America(developing only) to that in Middle East & North Africa (all income levels)?
Make the answer very short. 1.15. What is the ratio of the Rating (1=low 6=high) in 2008 in Latin America(developing only) to that in Middle East & North Africa (all income levels)?
Your answer should be compact. 1.16. What is the ratio of the Rating (1=low 6=high) in 2005 in Least developed countries to that in Low & middle income?
Offer a very short reply. 0.95. What is the ratio of the Rating (1=low 6=high) in 2006 in Least developed countries to that in Low & middle income?
Your response must be concise. 0.95. What is the ratio of the Rating (1=low 6=high) of 2007 in Least developed countries to that in Low & middle income?
Make the answer very short. 0.95. What is the ratio of the Rating (1=low 6=high) of 2008 in Least developed countries to that in Low & middle income?
Offer a very short reply. 0.94. What is the ratio of the Rating (1=low 6=high) in 2005 in Least developed countries to that in Low income?
Your answer should be very brief. 1. What is the ratio of the Rating (1=low 6=high) in 2007 in Least developed countries to that in Low income?
Give a very brief answer. 1. What is the ratio of the Rating (1=low 6=high) of 2008 in Least developed countries to that in Low income?
Keep it short and to the point. 1.01. What is the ratio of the Rating (1=low 6=high) in 2005 in Least developed countries to that in Lower middle income?
Your answer should be compact. 0.94. What is the ratio of the Rating (1=low 6=high) in 2006 in Least developed countries to that in Lower middle income?
Keep it short and to the point. 0.93. What is the ratio of the Rating (1=low 6=high) in 2007 in Least developed countries to that in Lower middle income?
Provide a succinct answer. 0.93. What is the ratio of the Rating (1=low 6=high) in 2008 in Least developed countries to that in Lower middle income?
Ensure brevity in your answer.  0.92. What is the ratio of the Rating (1=low 6=high) in 2007 in Least developed countries to that in Middle East & North Africa (all income levels)?
Make the answer very short. 1. What is the ratio of the Rating (1=low 6=high) in 2008 in Least developed countries to that in Middle East & North Africa (all income levels)?
Ensure brevity in your answer.  1. What is the ratio of the Rating (1=low 6=high) in 2005 in Low & middle income to that in Low income?
Offer a very short reply. 1.05. What is the ratio of the Rating (1=low 6=high) of 2006 in Low & middle income to that in Low income?
Your response must be concise. 1.06. What is the ratio of the Rating (1=low 6=high) of 2007 in Low & middle income to that in Low income?
Keep it short and to the point. 1.06. What is the ratio of the Rating (1=low 6=high) in 2008 in Low & middle income to that in Low income?
Give a very brief answer. 1.07. What is the ratio of the Rating (1=low 6=high) of 2005 in Low & middle income to that in Lower middle income?
Make the answer very short. 0.98. What is the ratio of the Rating (1=low 6=high) in 2006 in Low & middle income to that in Lower middle income?
Keep it short and to the point. 0.98. What is the ratio of the Rating (1=low 6=high) of 2007 in Low & middle income to that in Lower middle income?
Offer a very short reply. 0.98. What is the ratio of the Rating (1=low 6=high) of 2008 in Low & middle income to that in Lower middle income?
Give a very brief answer. 0.98. What is the ratio of the Rating (1=low 6=high) in 2005 in Low & middle income to that in Middle East & North Africa (all income levels)?
Offer a very short reply. 1.04. What is the ratio of the Rating (1=low 6=high) in 2006 in Low & middle income to that in Middle East & North Africa (all income levels)?
Provide a short and direct response. 1.04. What is the ratio of the Rating (1=low 6=high) in 2007 in Low & middle income to that in Middle East & North Africa (all income levels)?
Keep it short and to the point. 1.05. What is the ratio of the Rating (1=low 6=high) of 2008 in Low & middle income to that in Middle East & North Africa (all income levels)?
Your answer should be compact. 1.06. What is the ratio of the Rating (1=low 6=high) in 2005 in Low income to that in Lower middle income?
Ensure brevity in your answer.  0.93. What is the ratio of the Rating (1=low 6=high) of 2006 in Low income to that in Lower middle income?
Provide a short and direct response. 0.93. What is the ratio of the Rating (1=low 6=high) in 2007 in Low income to that in Lower middle income?
Ensure brevity in your answer.  0.93. What is the ratio of the Rating (1=low 6=high) in 2008 in Low income to that in Lower middle income?
Ensure brevity in your answer.  0.91. What is the ratio of the Rating (1=low 6=high) in 2005 in Low income to that in Middle East & North Africa (all income levels)?
Your answer should be very brief. 0.99. What is the ratio of the Rating (1=low 6=high) of 2006 in Low income to that in Middle East & North Africa (all income levels)?
Provide a short and direct response. 0.99. What is the ratio of the Rating (1=low 6=high) of 2008 in Low income to that in Middle East & North Africa (all income levels)?
Make the answer very short. 0.99. What is the ratio of the Rating (1=low 6=high) of 2005 in Lower middle income to that in Middle East & North Africa (all income levels)?
Provide a succinct answer. 1.06. What is the ratio of the Rating (1=low 6=high) of 2006 in Lower middle income to that in Middle East & North Africa (all income levels)?
Make the answer very short. 1.06. What is the ratio of the Rating (1=low 6=high) in 2007 in Lower middle income to that in Middle East & North Africa (all income levels)?
Give a very brief answer. 1.07. What is the ratio of the Rating (1=low 6=high) in 2008 in Lower middle income to that in Middle East & North Africa (all income levels)?
Keep it short and to the point. 1.08. What is the difference between the highest and the second highest Rating (1=low 6=high) in 2005?
Give a very brief answer. 0.27. What is the difference between the highest and the second highest Rating (1=low 6=high) in 2006?
Offer a terse response. 0.33. What is the difference between the highest and the second highest Rating (1=low 6=high) of 2007?
Provide a succinct answer. 0.25. What is the difference between the highest and the second highest Rating (1=low 6=high) of 2008?
Provide a short and direct response. 0.26. What is the difference between the highest and the lowest Rating (1=low 6=high) of 2005?
Offer a terse response. 0.51. What is the difference between the highest and the lowest Rating (1=low 6=high) in 2006?
Offer a terse response. 0.58. What is the difference between the highest and the lowest Rating (1=low 6=high) of 2007?
Offer a terse response. 0.5. What is the difference between the highest and the lowest Rating (1=low 6=high) of 2008?
Provide a succinct answer. 0.57. 